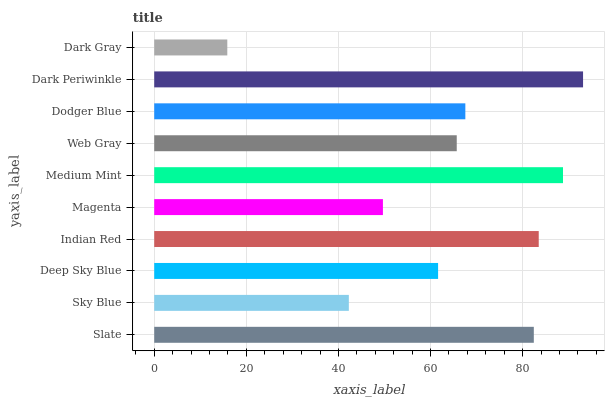Is Dark Gray the minimum?
Answer yes or no. Yes. Is Dark Periwinkle the maximum?
Answer yes or no. Yes. Is Sky Blue the minimum?
Answer yes or no. No. Is Sky Blue the maximum?
Answer yes or no. No. Is Slate greater than Sky Blue?
Answer yes or no. Yes. Is Sky Blue less than Slate?
Answer yes or no. Yes. Is Sky Blue greater than Slate?
Answer yes or no. No. Is Slate less than Sky Blue?
Answer yes or no. No. Is Dodger Blue the high median?
Answer yes or no. Yes. Is Web Gray the low median?
Answer yes or no. Yes. Is Slate the high median?
Answer yes or no. No. Is Dark Periwinkle the low median?
Answer yes or no. No. 